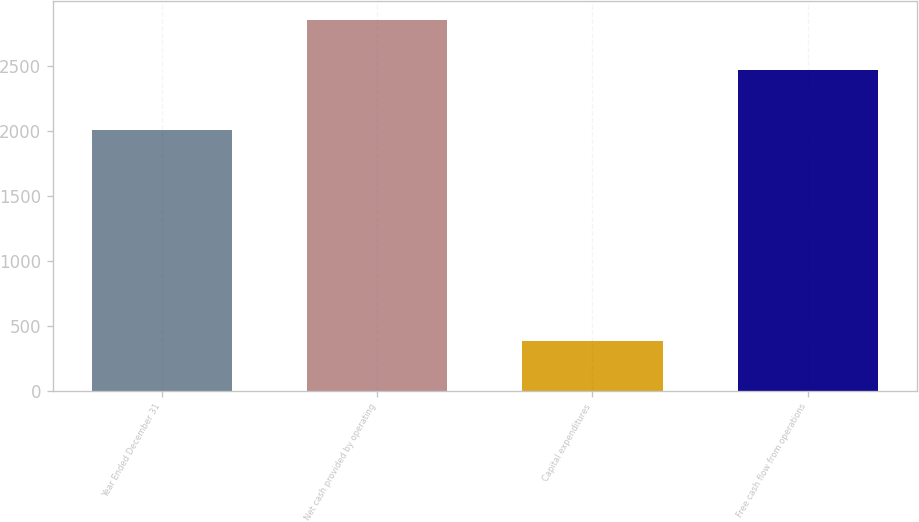<chart> <loc_0><loc_0><loc_500><loc_500><bar_chart><fcel>Year Ended December 31<fcel>Net cash provided by operating<fcel>Capital expenditures<fcel>Free cash flow from operations<nl><fcel>2009<fcel>2855<fcel>385<fcel>2470<nl></chart> 